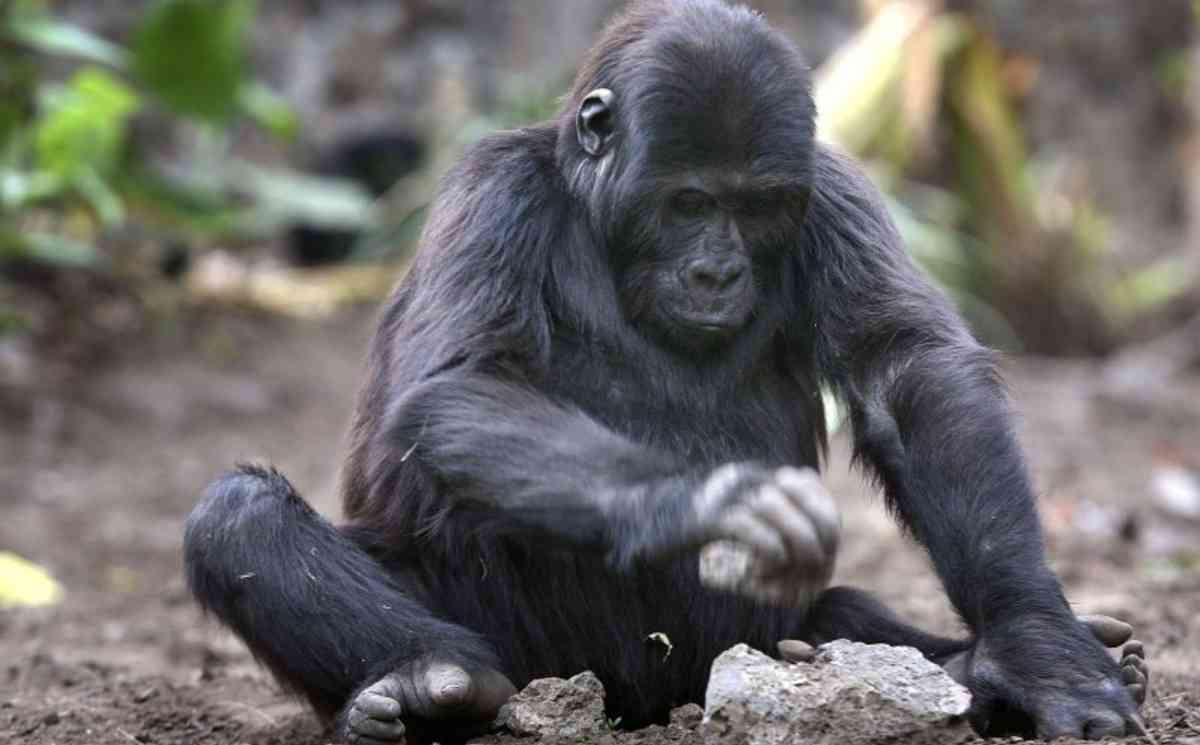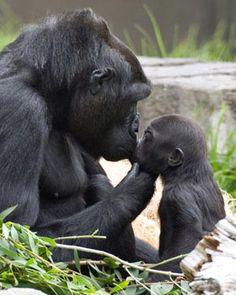The first image is the image on the left, the second image is the image on the right. For the images displayed, is the sentence "One of the images shows exactly one adult gorilla and one baby gorilla in close proximity." factually correct? Answer yes or no. Yes. The first image is the image on the left, the second image is the image on the right. Analyze the images presented: Is the assertion "An image shows a baby gorilla on the right and one adult gorilla, which is sitting on the left." valid? Answer yes or no. Yes. 